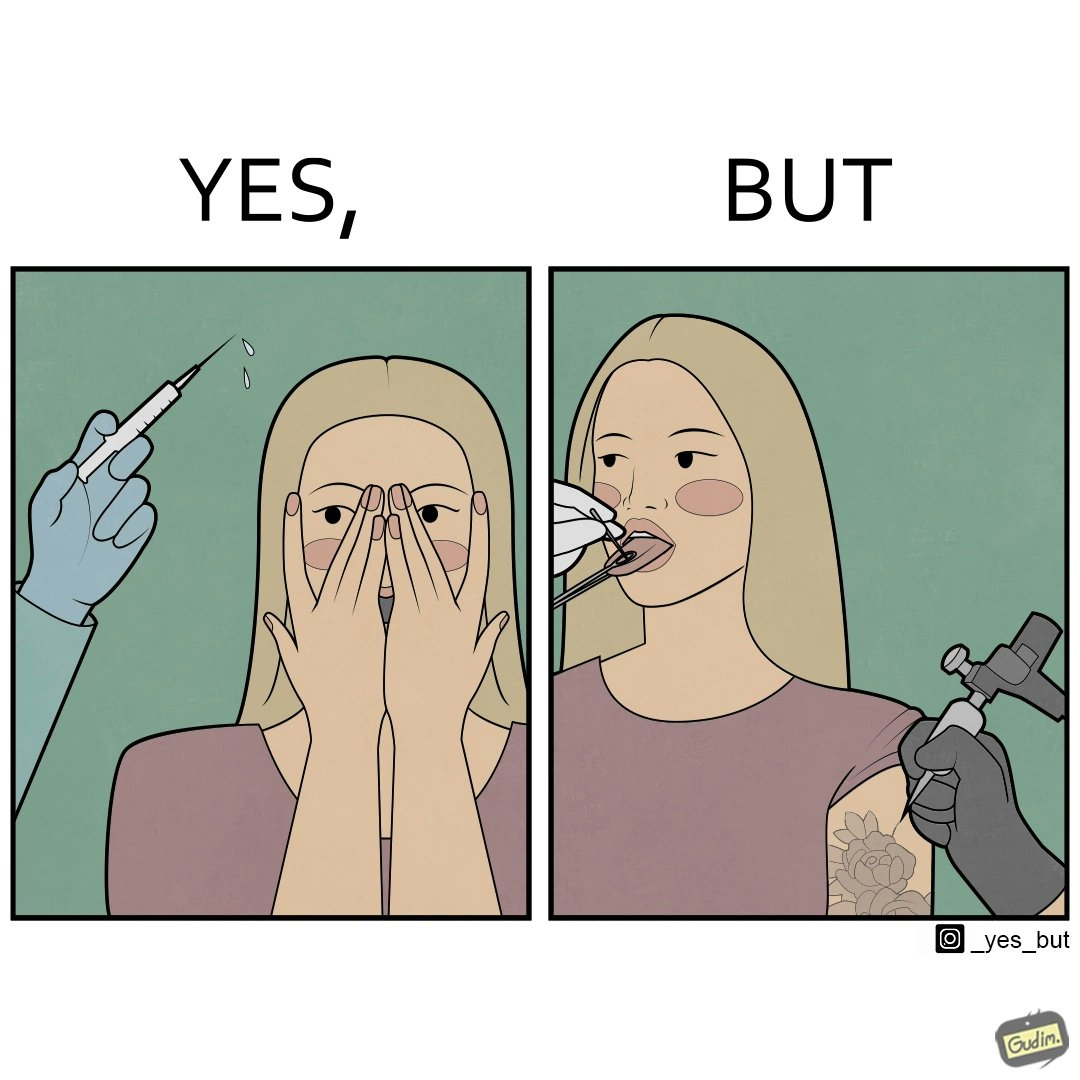What makes this image funny or satirical? The image is funny becuase while the woman is scared of getting an injection which is for her benefit, she is not afraid of getting a piercing or a tattoo which are not going to help her in any way. 